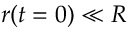<formula> <loc_0><loc_0><loc_500><loc_500>r ( t = 0 ) \ll R</formula> 